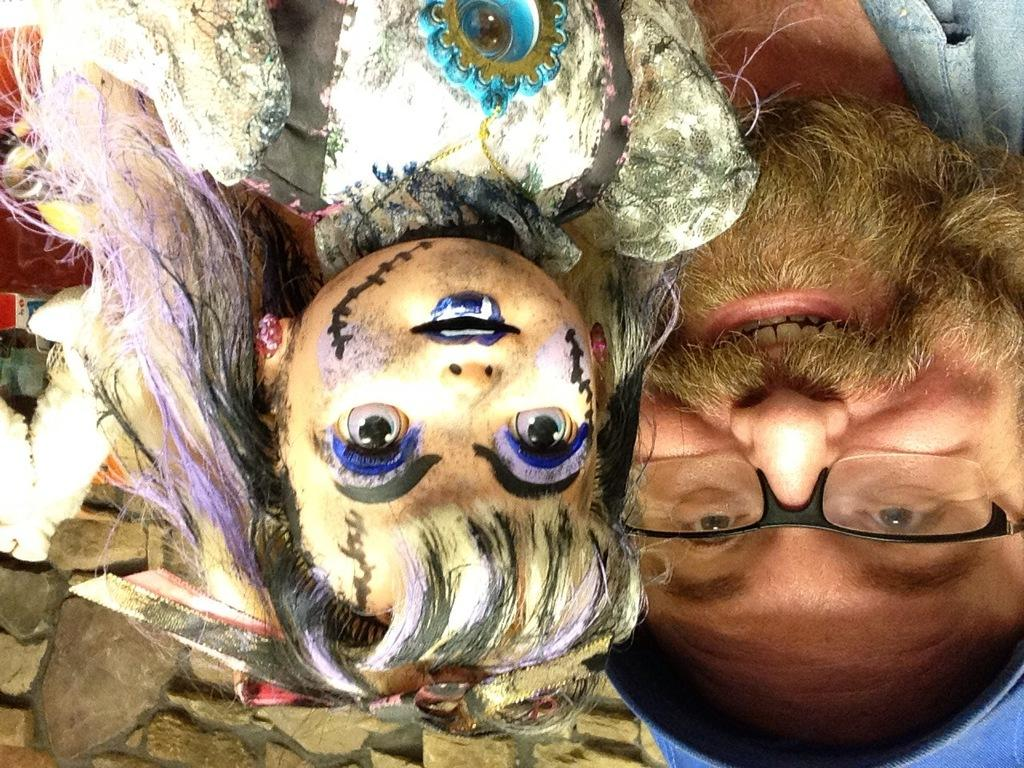What is the appearance of the man in the image? The man in the image has a beard and glasses. What other characters are present in the image? There is a devil and another devil-like figure in the image. How many voices can be heard coming from the man in the image? There is no indication of any voices in the image, so it's not possible to determine how many voices might be heard. 